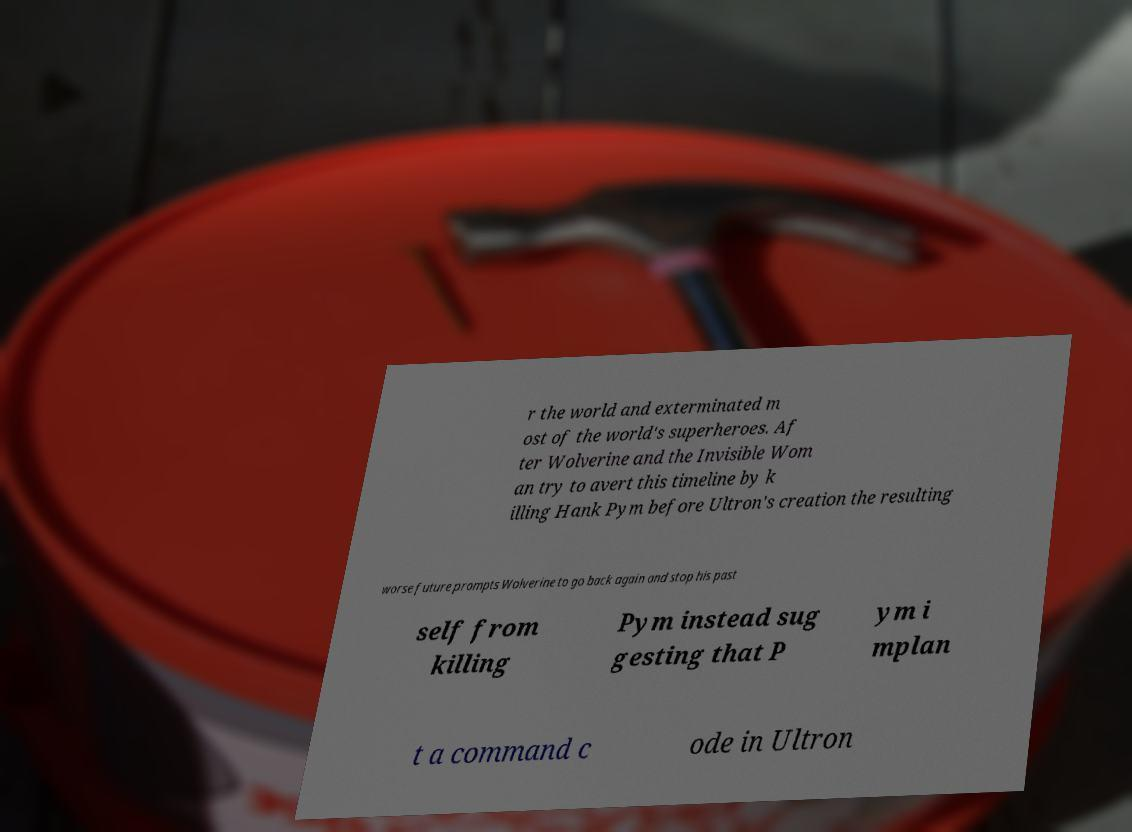For documentation purposes, I need the text within this image transcribed. Could you provide that? r the world and exterminated m ost of the world's superheroes. Af ter Wolverine and the Invisible Wom an try to avert this timeline by k illing Hank Pym before Ultron's creation the resulting worse future prompts Wolverine to go back again and stop his past self from killing Pym instead sug gesting that P ym i mplan t a command c ode in Ultron 